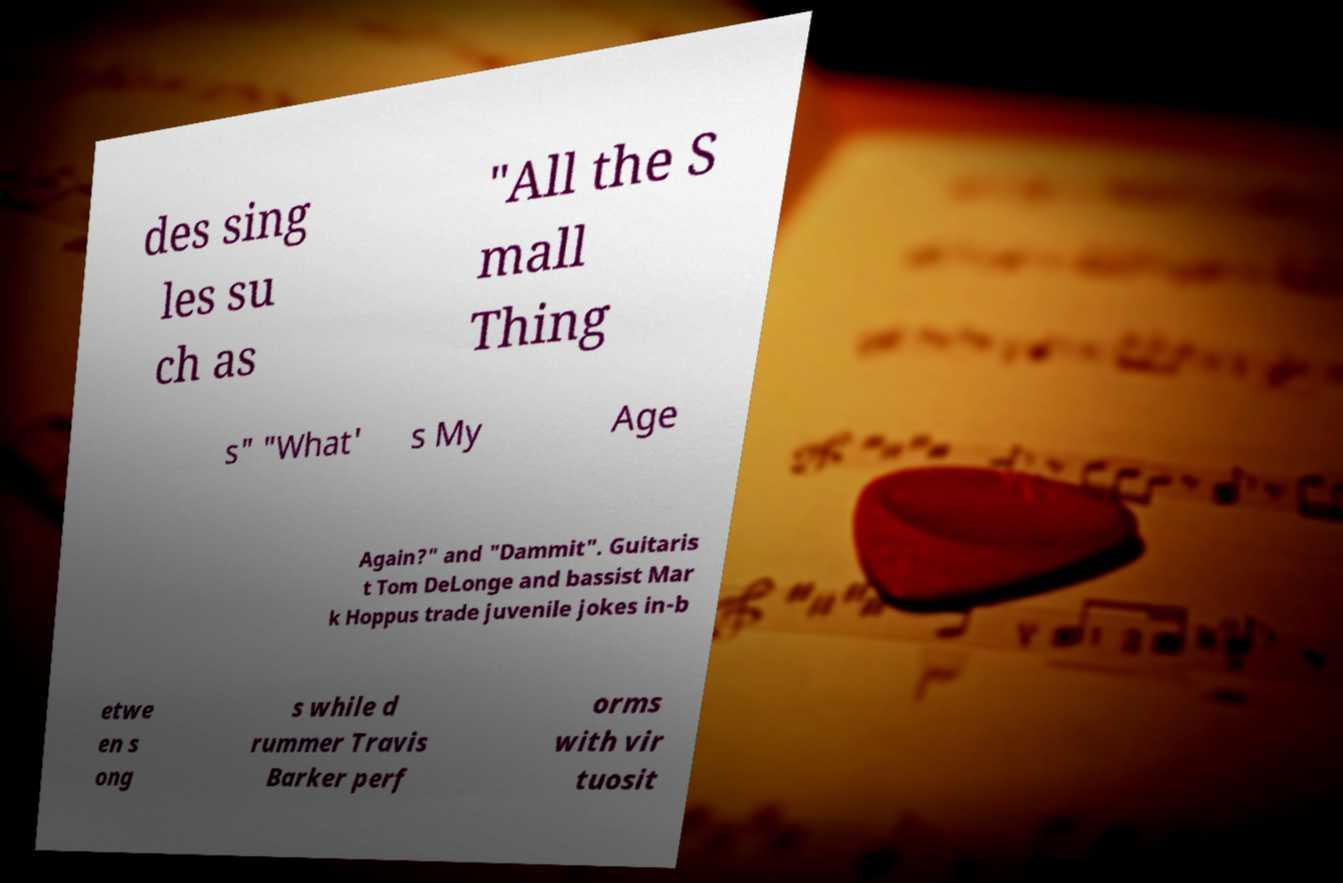What messages or text are displayed in this image? I need them in a readable, typed format. des sing les su ch as "All the S mall Thing s" "What' s My Age Again?" and "Dammit". Guitaris t Tom DeLonge and bassist Mar k Hoppus trade juvenile jokes in-b etwe en s ong s while d rummer Travis Barker perf orms with vir tuosit 